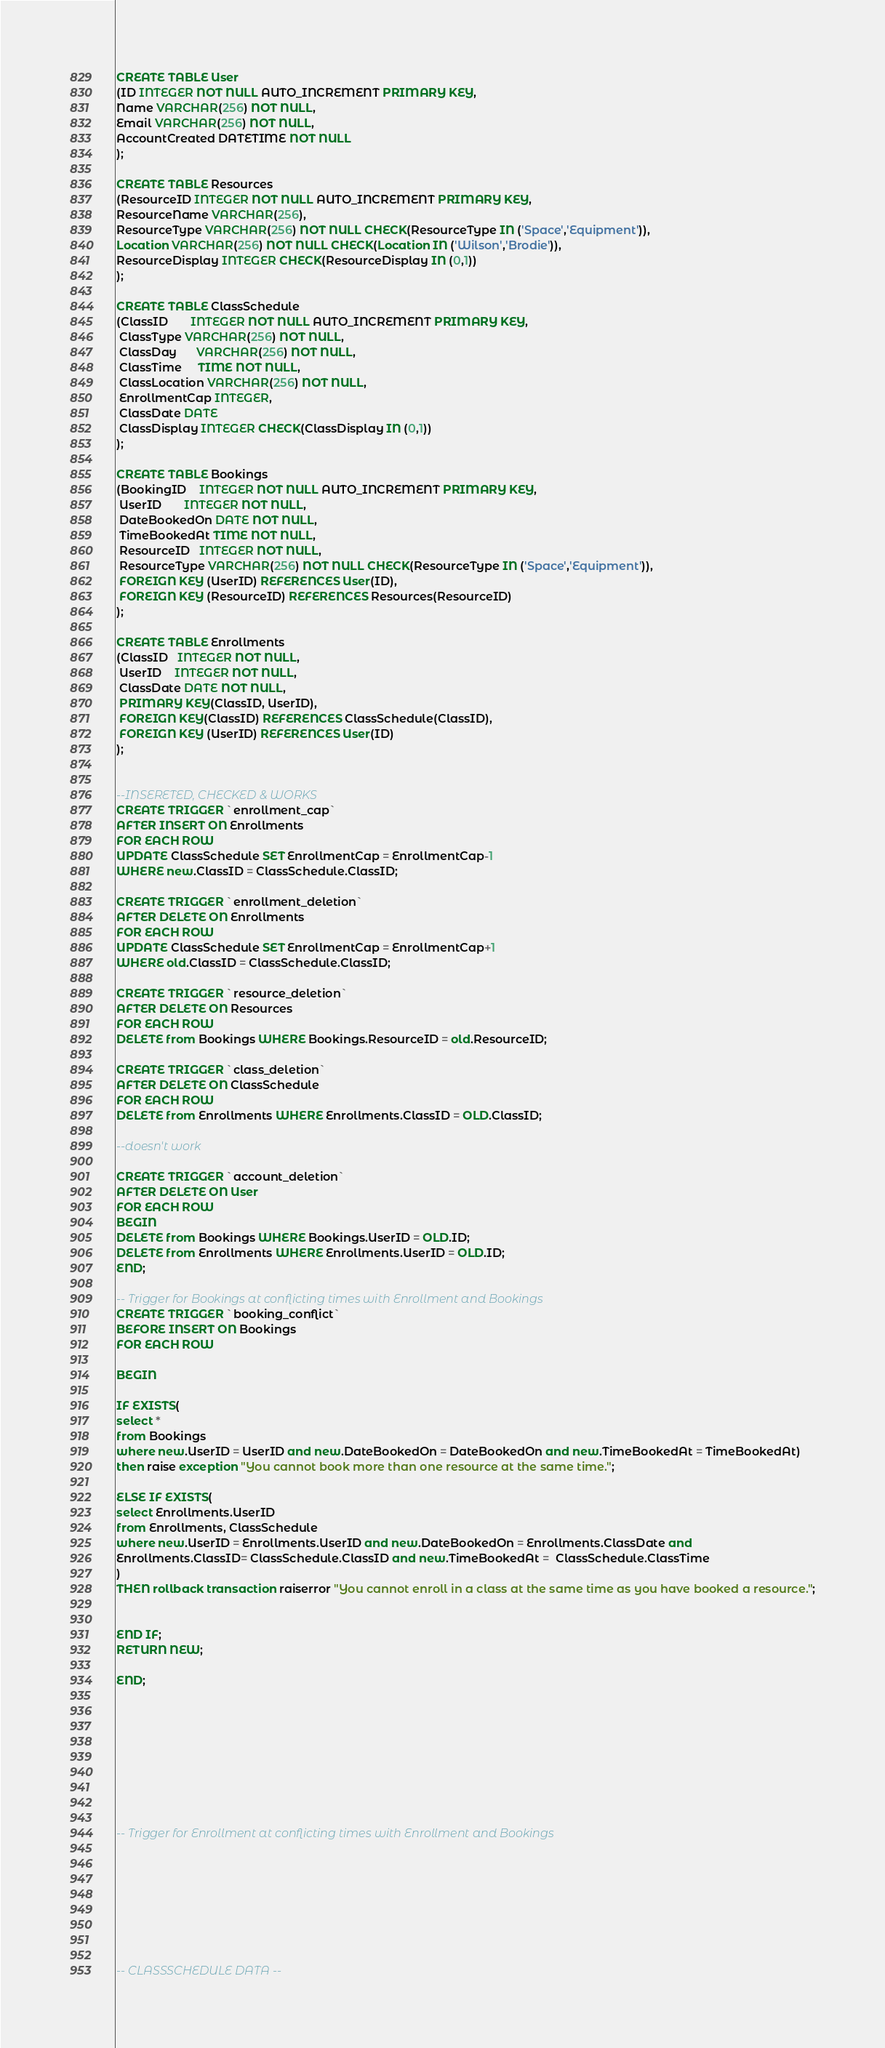Convert code to text. <code><loc_0><loc_0><loc_500><loc_500><_SQL_>CREATE TABLE User
(ID INTEGER NOT NULL AUTO_INCREMENT PRIMARY KEY,
Name VARCHAR(256) NOT NULL,
Email VARCHAR(256) NOT NULL,
AccountCreated DATETIME NOT NULL
);

CREATE TABLE Resources 
(ResourceID INTEGER NOT NULL AUTO_INCREMENT PRIMARY KEY,
ResourceName VARCHAR(256), 
ResourceType VARCHAR(256) NOT NULL CHECK(ResourceType IN ('Space','Equipment')), 
Location VARCHAR(256) NOT NULL CHECK(Location IN ('Wilson','Brodie')),
ResourceDisplay INTEGER CHECK(ResourceDisplay IN (0,1))
);

CREATE TABLE ClassSchedule
(ClassID       INTEGER NOT NULL AUTO_INCREMENT PRIMARY KEY, 
 ClassType VARCHAR(256) NOT NULL, 
 ClassDay      VARCHAR(256) NOT NULL, 
 ClassTime     TIME NOT NULL, 
 ClassLocation VARCHAR(256) NOT NULL, 
 EnrollmentCap INTEGER,
 ClassDate DATE
 ClassDisplay INTEGER CHECK(ClassDisplay IN (0,1))
);

CREATE TABLE Bookings
(BookingID    INTEGER NOT NULL AUTO_INCREMENT PRIMARY KEY, 
 UserID       INTEGER NOT NULL, 
 DateBookedOn DATE NOT NULL, 
 TimeBookedAt TIME NOT NULL, 
 ResourceID   INTEGER NOT NULL, 
 ResourceType VARCHAR(256) NOT NULL CHECK(ResourceType IN ('Space','Equipment')),
 FOREIGN KEY (UserID) REFERENCES User(ID),
 FOREIGN KEY (ResourceID) REFERENCES Resources(ResourceID)
);

CREATE TABLE Enrollments
(ClassID   INTEGER NOT NULL, 
 UserID    INTEGER NOT NULL, 
 ClassDate DATE NOT NULL,
 PRIMARY KEY(ClassID, UserID), 
 FOREIGN KEY(ClassID) REFERENCES ClassSchedule(ClassID),
 FOREIGN KEY (UserID) REFERENCES User(ID)
);


--INSERETED, CHECKED & WORKS
CREATE TRIGGER `enrollment_cap` 
AFTER INSERT ON Enrollments 
FOR EACH ROW
UPDATE ClassSchedule SET EnrollmentCap = EnrollmentCap-1 
WHERE new.ClassID = ClassSchedule.ClassID;

CREATE TRIGGER `enrollment_deletion` 
AFTER DELETE ON Enrollments 
FOR EACH ROW
UPDATE ClassSchedule SET EnrollmentCap = EnrollmentCap+1 
WHERE old.ClassID = ClassSchedule.ClassID;

CREATE TRIGGER `resource_deletion` 
AFTER DELETE ON Resources 
FOR EACH ROW
DELETE from Bookings WHERE Bookings.ResourceID = old.ResourceID;

CREATE TRIGGER `class_deletion` 
AFTER DELETE ON ClassSchedule 
FOR EACH ROW
DELETE from Enrollments WHERE Enrollments.ClassID = OLD.ClassID;

--doesn't work

CREATE TRIGGER `account_deletion` 
AFTER DELETE ON User 
FOR EACH ROW
BEGIN
DELETE from Bookings WHERE Bookings.UserID = OLD.ID;
DELETE from Enrollments WHERE Enrollments.UserID = OLD.ID;
END;

-- Trigger for Bookings at conflicting times with Enrollment and Bookings
CREATE TRIGGER `booking_conflict` 
BEFORE INSERT ON Bookings 
FOR EACH ROW

BEGIN

IF EXISTS( 
select *
from Bookings
where new.UserID = UserID and new.DateBookedOn = DateBookedOn and new.TimeBookedAt = TimeBookedAt)
then raise exception "You cannot book more than one resource at the same time.";

ELSE IF EXISTS(
select Enrollments.UserID
from Enrollments, ClassSchedule
where new.UserID = Enrollments.UserID and new.DateBookedOn = Enrollments.ClassDate and 
Enrollments.ClassID= ClassSchedule.ClassID and new.TimeBookedAt =  ClassSchedule.ClassTime
) 
THEN rollback transaction raiserror "You cannot enroll in a class at the same time as you have booked a resource.";


END IF;
RETURN NEW;

END;









-- Trigger for Enrollment at conflicting times with Enrollment and Bookings








-- CLASSSCHEDULE DATA --
</code> 